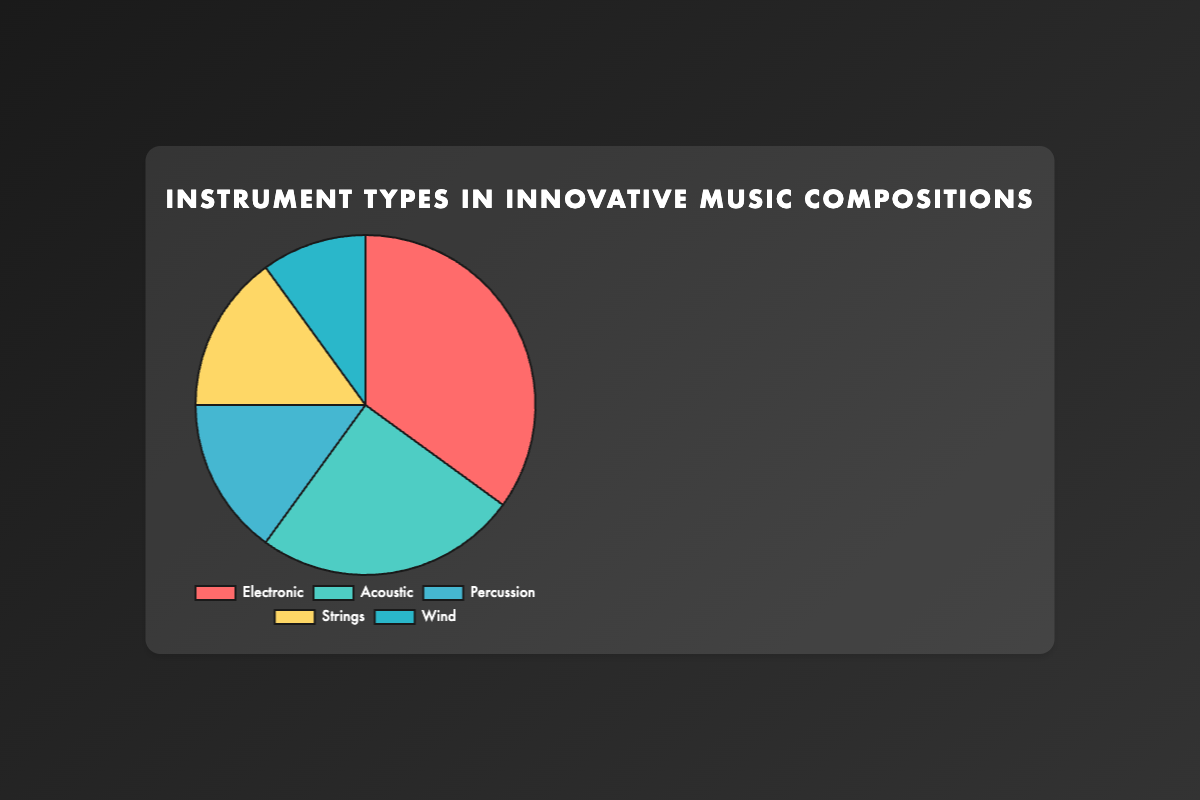What is the percentage of Electronic instruments in innovative music compositions? The pie chart shows the distribution of instruments with their corresponding percentages. The Electronic section is labeled with 35%.
Answer: 35% Which type of instruments has the smallest representation in the chart? By observing the pie chart, the segment representing the Wind instruments is the smallest, labeled with 10%.
Answer: Wind How much larger is the percentage of Electronic instruments compared to Percussion instruments? The Electronic instruments are 35%, and the Percussion instruments are 15%. The difference is 35% - 15% = 20%.
Answer: 20% What is the total percentage of Acoustic and Strings instruments combined? The pie chart shows Acoustic at 25% and Strings at 15%. Adding these together, 25% + 15% = 40%.
Answer: 40% Which two types of instruments collectively make up half of the distribution? Checking the percentages for each type, we see Electronic is 35% and Acoustic is 25%. Together, they make up 35% + 25% = 60%. However, Acoustic (25%) and Strings (15%) sum up to 40%, Percussion (15%) and Strings (15%) sum to 30%. Thus, there is no exact combination for half, but the closest is Electronic (35%) and Percussion (15%) together making 50%.
Answer: Electronic and Percussion What is the visual representation color for Percussion instruments? The pie chart uses distinct colors. The Percussion section is colored in light blue.
Answer: Light blue Which type of instrument is represented by the yellow section? Examining the colors assigned in the pie chart, the yellow section represents the Strings instruments.
Answer: Strings If Electronic and Acoustic instruments are merged into a single category, what percentage does it represent? Adding the percentages of Electronic (35%) and Acoustic (25%) gives us 35% + 25% = 60%.
Answer: 60% How does the percentage of Acoustic instruments compare to Wind instruments? The Acoustic instruments are 25%, and the Wind instruments are 10%. Acoustic instruments therefore are greater by 25% - 10% = 15%.
Answer: 15% greater How many types of instruments have a representation of 15% each? By observing the chart, both Percussion and Strings have a representation of 15%. Hence, there are 2 types of instruments with a representation of 15% each.
Answer: 2 